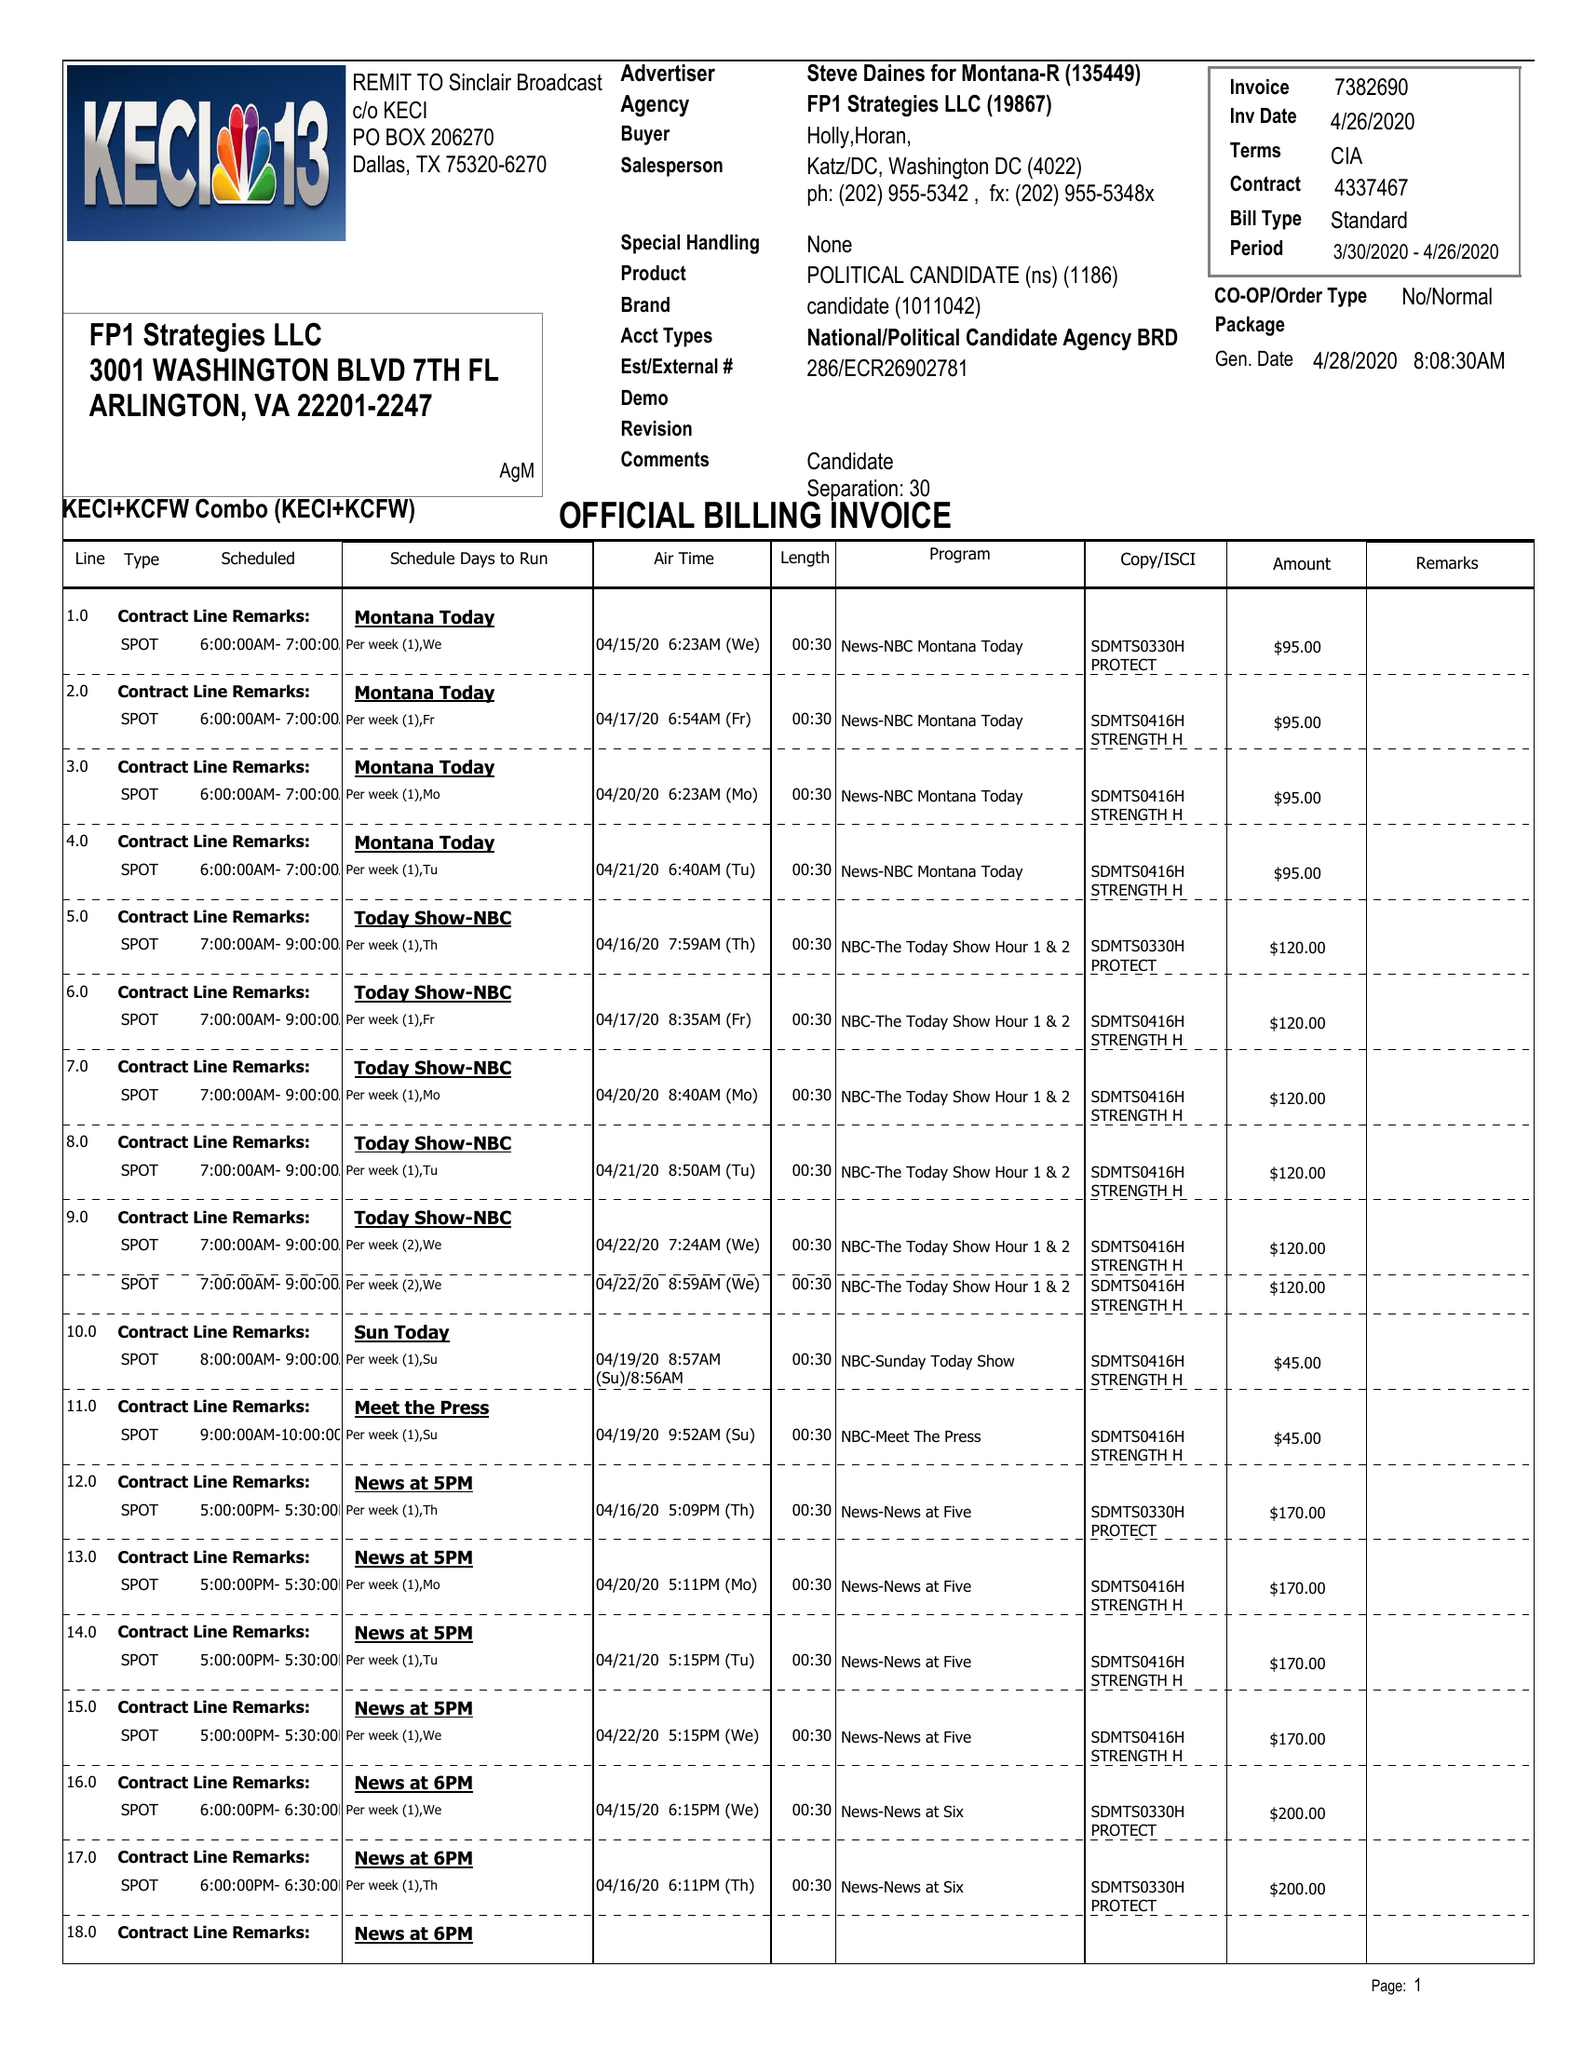What is the value for the flight_to?
Answer the question using a single word or phrase. 04/26/20 